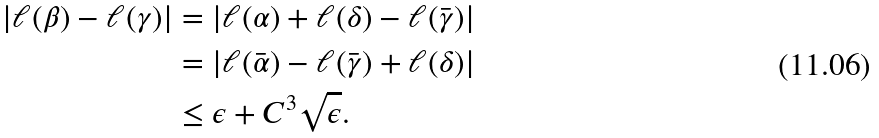Convert formula to latex. <formula><loc_0><loc_0><loc_500><loc_500>| \ell ( \beta ) - \ell ( \gamma ) | & = | \ell ( \alpha ) + \ell ( \delta ) - \ell ( \bar { \gamma } ) | \\ & = | \ell ( \bar { \alpha } ) - \ell ( \bar { \gamma } ) + \ell ( \delta ) | \\ & \leq \epsilon + C ^ { 3 } \sqrt { \epsilon } .</formula> 